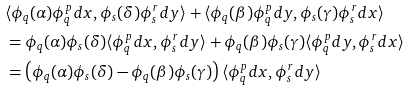Convert formula to latex. <formula><loc_0><loc_0><loc_500><loc_500>& \langle \phi _ { q } ( \alpha ) \phi ^ { p } _ { q } d x , \phi _ { s } ( \delta ) \phi ^ { r } _ { s } d y \rangle + \langle \phi _ { q } ( \beta ) \phi ^ { p } _ { q } d y , \phi _ { s } ( \gamma ) \phi ^ { r } _ { s } d x \rangle \\ & = \phi _ { q } ( \alpha ) \phi _ { s } ( \delta ) \langle \phi ^ { p } _ { q } d x , \phi ^ { r } _ { s } d y \rangle + \phi _ { q } ( \beta ) \phi _ { s } ( \gamma ) \langle \phi ^ { p } _ { q } d y , \phi ^ { r } _ { s } d x \rangle \\ & = \left ( \phi _ { q } ( \alpha ) \phi _ { s } ( \delta ) - \phi _ { q } ( \beta ) \phi _ { s } ( \gamma ) \right ) \langle \phi ^ { p } _ { q } d x , \phi ^ { r } _ { s } d y \rangle</formula> 